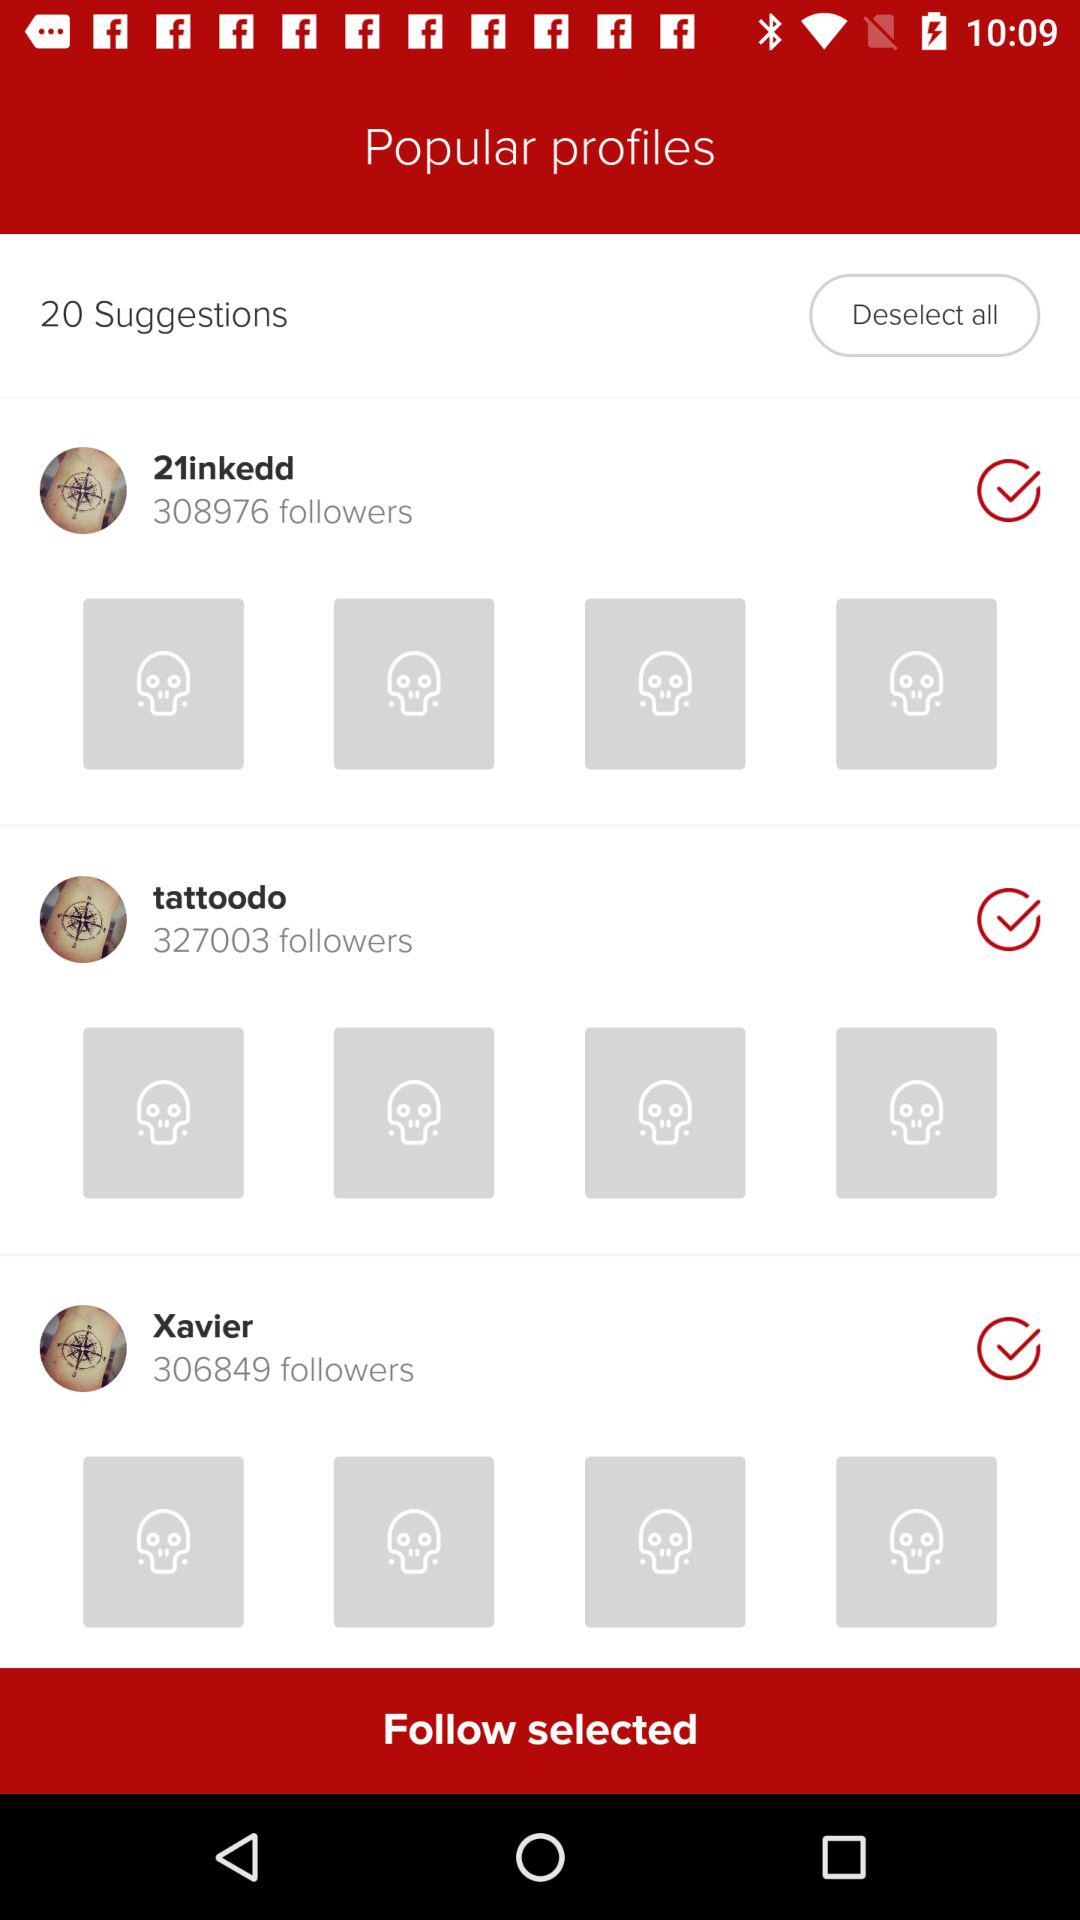How many followers are shown of Xavier? There are 306849 followers. 